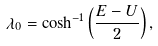Convert formula to latex. <formula><loc_0><loc_0><loc_500><loc_500>\lambda _ { 0 } = \cosh ^ { - 1 } \left ( \frac { E - U } { 2 } \right ) ,</formula> 